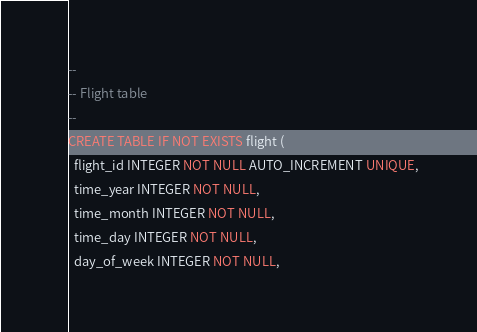<code> <loc_0><loc_0><loc_500><loc_500><_SQL_>--
-- Flight table
--
CREATE TABLE IF NOT EXISTS flight (
  flight_id INTEGER NOT NULL AUTO_INCREMENT UNIQUE,
  time_year INTEGER NOT NULL,
  time_month INTEGER NOT NULL,
  time_day INTEGER NOT NULL,
  day_of_week INTEGER NOT NULL,</code> 